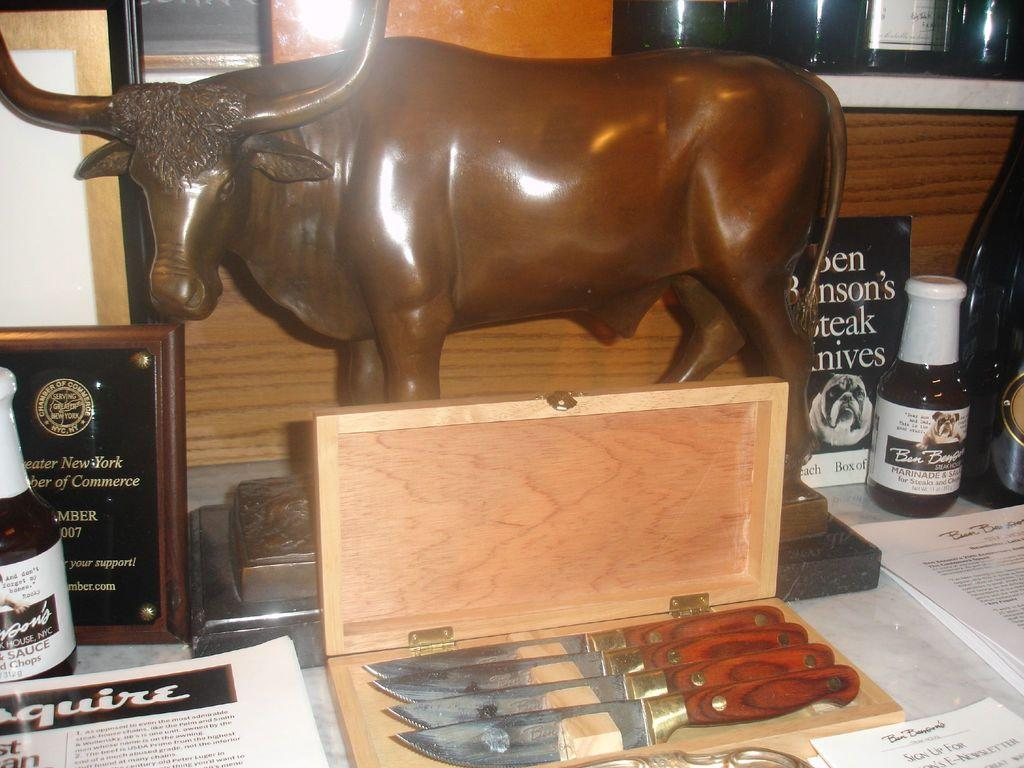What is present on the surface in the image? There are papers, a wooden box containing knives, bottles, and a statue on the surface. Can you describe the wooden box in more detail? The wooden box contains knives, as mentioned in the fact. What else can be seen on the surface besides the mentioned items? There are other unspecified things on the surface. How many buildings can be seen in the image? There are no buildings present in the image; it features a surface with various objects on it. What type of hen is sitting on the statue in the image? There is no hen present in the image; it features a surface with various objects, including a statue, but no hen. 